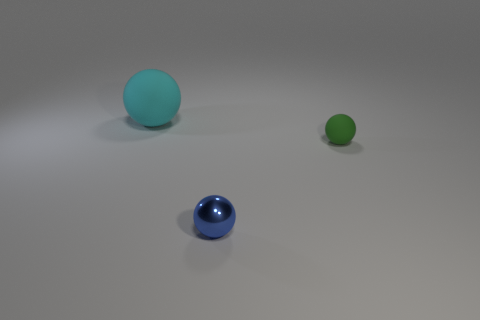Subtract all small balls. How many balls are left? 1 Subtract all blue spheres. How many spheres are left? 2 Add 2 large cyan balls. How many objects exist? 5 Subtract 0 brown spheres. How many objects are left? 3 Subtract 2 balls. How many balls are left? 1 Subtract all brown spheres. Subtract all red blocks. How many spheres are left? 3 Subtract all cyan blocks. How many cyan spheres are left? 1 Subtract all tiny yellow blocks. Subtract all big cyan balls. How many objects are left? 2 Add 1 green balls. How many green balls are left? 2 Add 1 small green metallic spheres. How many small green metallic spheres exist? 1 